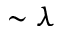Convert formula to latex. <formula><loc_0><loc_0><loc_500><loc_500>\sim \lambda</formula> 